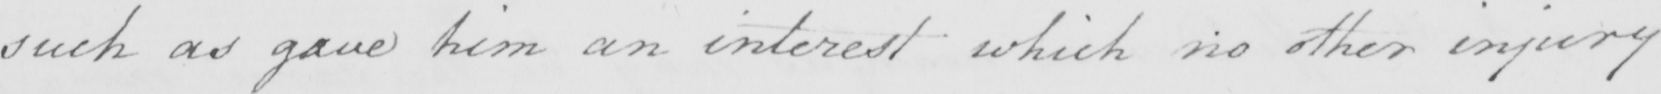Can you read and transcribe this handwriting? such as gave him an interest which no other injury 